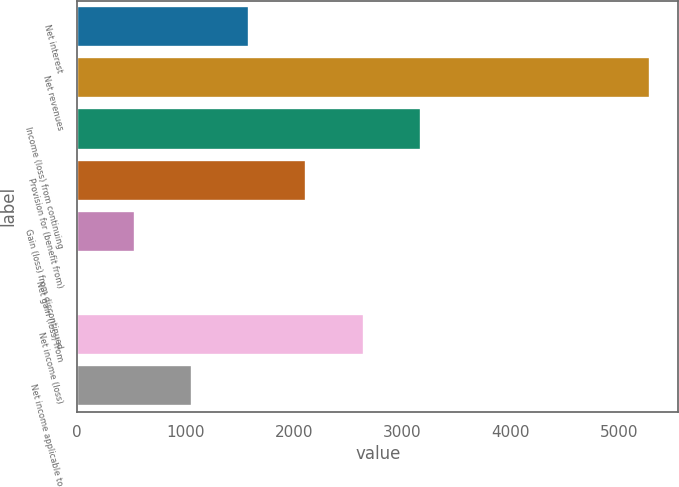<chart> <loc_0><loc_0><loc_500><loc_500><bar_chart><fcel>Net interest<fcel>Net revenues<fcel>Income (loss) from continuing<fcel>Provision for (benefit from)<fcel>Gain (loss) from discontinued<fcel>Net gain (loss) from<fcel>Net income (loss)<fcel>Net income applicable to<nl><fcel>1585.4<fcel>5280<fcel>3168.8<fcel>2113.2<fcel>529.8<fcel>2<fcel>2641<fcel>1057.6<nl></chart> 